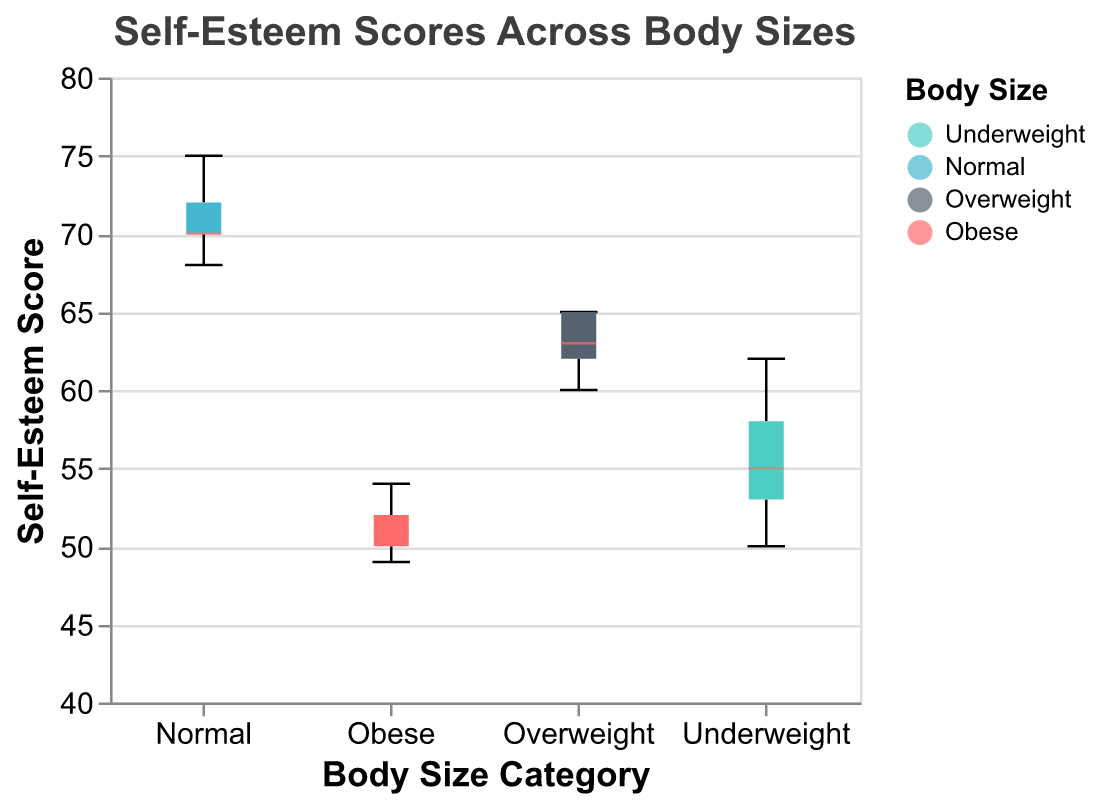What is the median Self-Esteem Score for individuals categorized as Normal body size? To find the median Self-Esteem Score for the Normal body size category, look at the line inside the box for the Normal category on the box plot.
Answer: 70 What is the range of Self-Esteem Scores for individuals categorized as Overweight? The range in a box plot can be observed from the minimum to the maximum point indicated. For the Overweight category, these values are marked by the lower and upper whiskers.
Answer: 60-65 Which body size category has the highest median Self-Esteem Score? Compare the lines inside each box for all categories to determine which one is highest. The Normal category has the highest median.
Answer: Normal What are the quartiles for the Underweight category? The quartiles are represented by the edges of the box and the median line within the Underweight category's box. The lower quartile (Q1), median (Q2), and upper quartile (Q3) are 53, 55, and 58, respectively.
Answer: 53, 55, 58 What's the interquartile range (IQR) for individuals categorized as Obese? To find the interquartile range (IQR) for the Obese category, subtract the value of the lower quartile (Q1) from the upper quartile (Q3). The lower quartile (Q1) is approximately 50, and the upper quartile (Q3) is about 52.
Answer: 2 How do the medians of Underweight and Obese categories compare? Compare the lines inside the boxes for the Underweight and Obese categories. The median for Underweight is higher than the median for Obese.
Answer: Underweight > Obese Is there any overlap in the Self-Esteem Scores between Overweight and Normal categories? Observe if the boxes or whiskers for Overweight and Normal overlap on the y-axis. There seems to be no overlap as Overweight peaks at 65 while Normal starts at 68.
Answer: No Between which two body size categories is the self-esteem score distribution the most similar? Compare the shapes, sizes, and positions of the boxes and whiskers. The Underweight and Obese categories have similar shapes and ranges.
Answer: Underweight and Obese What is the overall trend in the Self-Esteem Scores across the body size categories? Looking from left to right on the x-axis, Self-Esteem Scores generally decrease from Normal to Overweight and Obese.
Answer: Decreasing from Normal to Obese Which body size category shows the minimum recorded Self-Esteem Score, and what is that value? Look for the lowest point on the entire plot. The Obese category shows the minimum recorded Self-Esteem Score.
Answer: Obese, 49 